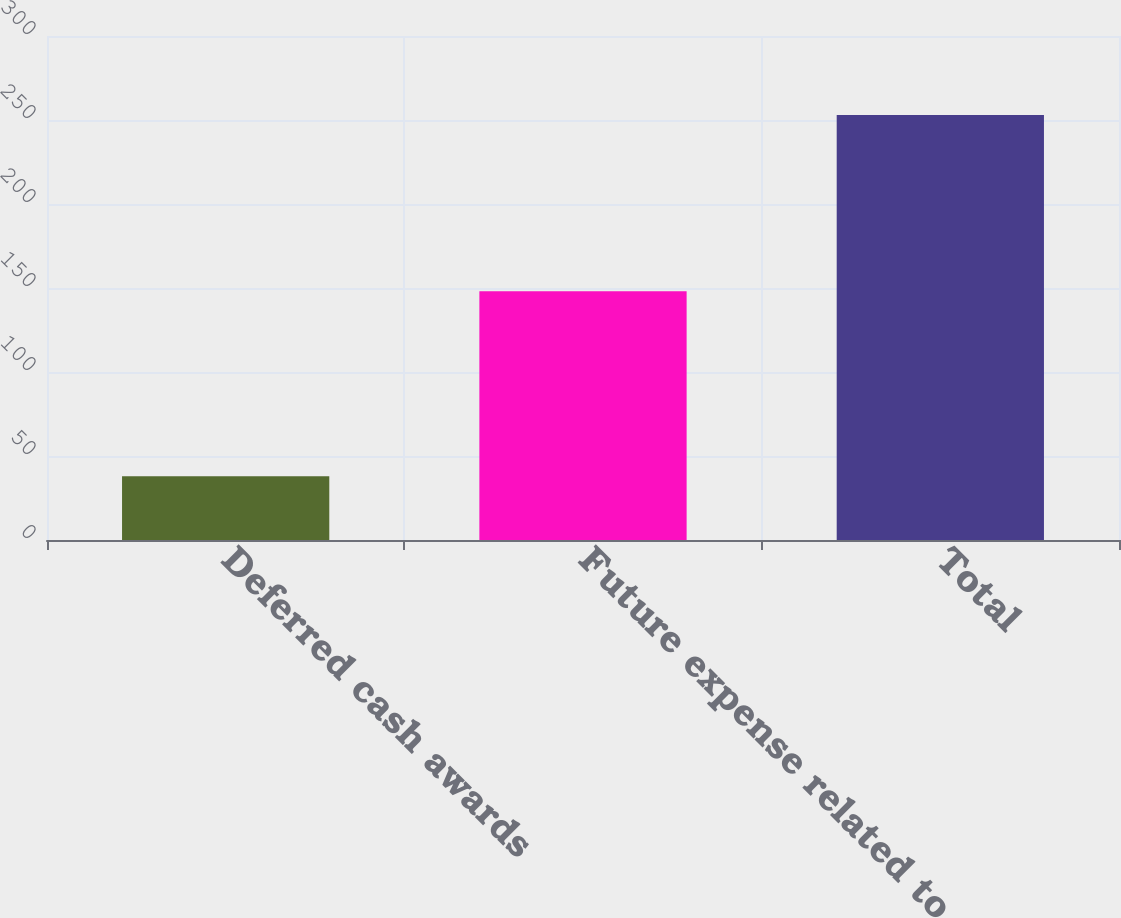Convert chart to OTSL. <chart><loc_0><loc_0><loc_500><loc_500><bar_chart><fcel>Deferred cash awards<fcel>Future expense related to<fcel>Total<nl><fcel>38<fcel>148<fcel>253<nl></chart> 